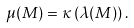<formula> <loc_0><loc_0><loc_500><loc_500>\mu ( M ) = \kappa \left ( \lambda ( M ) \right ) .</formula> 